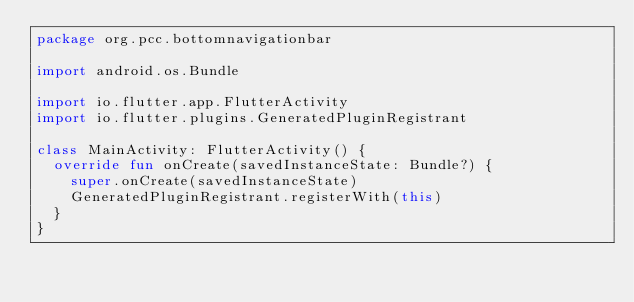Convert code to text. <code><loc_0><loc_0><loc_500><loc_500><_Kotlin_>package org.pcc.bottomnavigationbar

import android.os.Bundle

import io.flutter.app.FlutterActivity
import io.flutter.plugins.GeneratedPluginRegistrant

class MainActivity: FlutterActivity() {
  override fun onCreate(savedInstanceState: Bundle?) {
    super.onCreate(savedInstanceState)
    GeneratedPluginRegistrant.registerWith(this)
  }
}
</code> 